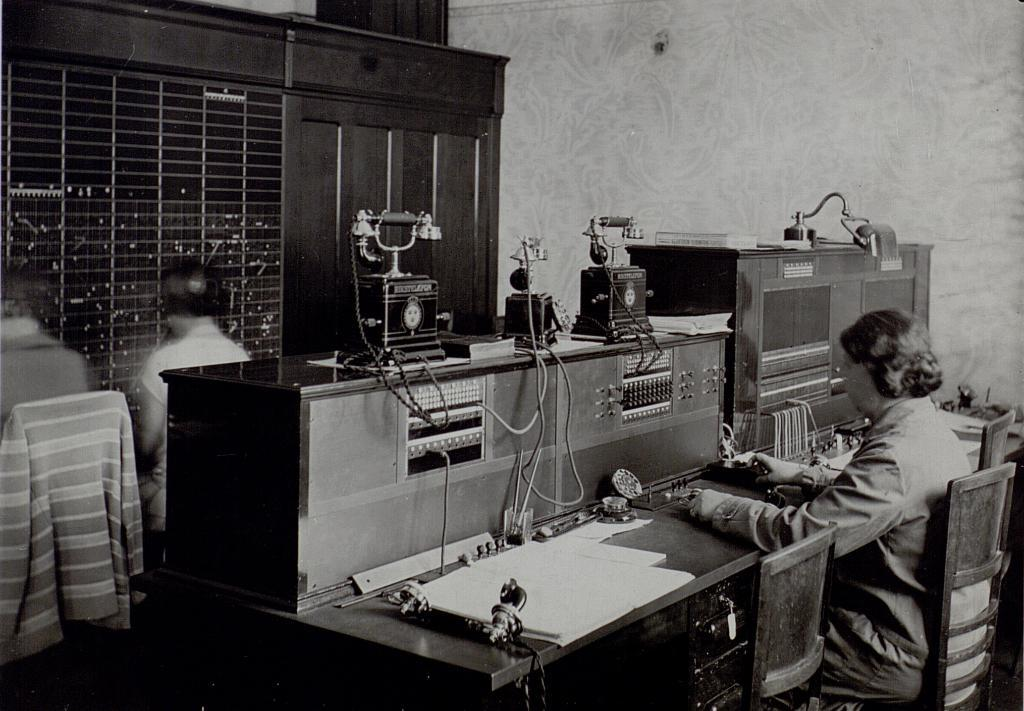What are the persons in the image doing? The persons in the image are sitting on chairs. What can be seen on the table in the image? There is a telephone and paper on the table. Are there any other objects on the table? Yes, there are other things on the table. What is visible in the background of the image? There is a wall in the background of the image. Can you tell me how many corks are on the table in the image? There is no mention of corks in the image, so we cannot determine how many are present. Is there a hole in the wall in the image? The image does not show any holes in the wall; it only shows a wall in the background. 